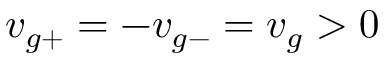Convert formula to latex. <formula><loc_0><loc_0><loc_500><loc_500>v _ { g + } = - v _ { g - } = v _ { g } > 0</formula> 